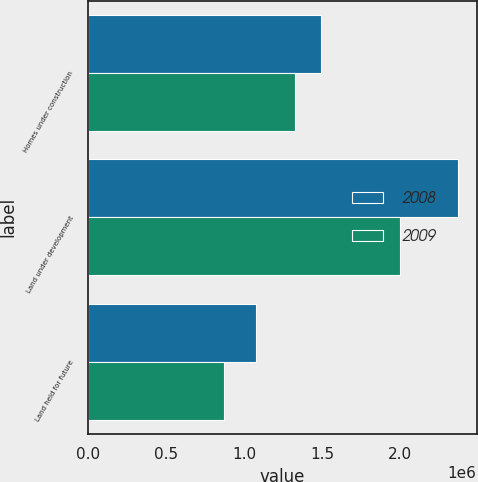Convert chart. <chart><loc_0><loc_0><loc_500><loc_500><stacked_bar_chart><ecel><fcel>Homes under construction<fcel>Land under development<fcel>Land held for future<nl><fcel>2008<fcel>1.49289e+06<fcel>2.37088e+06<fcel>1.07659e+06<nl><fcel>2009<fcel>1.32567e+06<fcel>2.00204e+06<fcel>873578<nl></chart> 